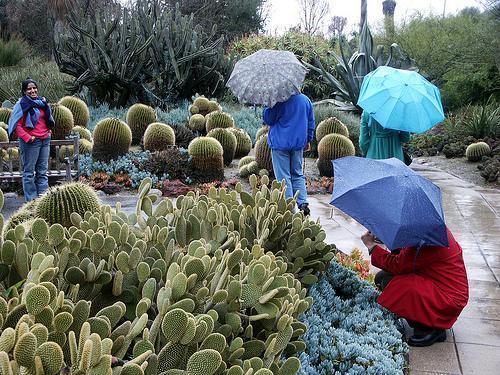How many umbrellas are there?
Give a very brief answer. 3. How many people are there?
Give a very brief answer. 4. 